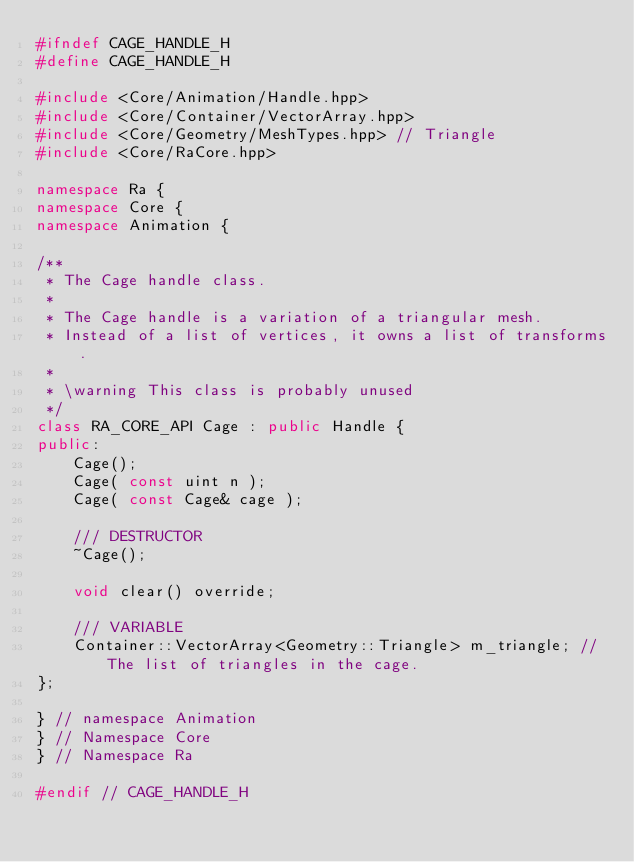<code> <loc_0><loc_0><loc_500><loc_500><_C++_>#ifndef CAGE_HANDLE_H
#define CAGE_HANDLE_H

#include <Core/Animation/Handle.hpp>
#include <Core/Container/VectorArray.hpp>
#include <Core/Geometry/MeshTypes.hpp> // Triangle
#include <Core/RaCore.hpp>

namespace Ra {
namespace Core {
namespace Animation {

/**
 * The Cage handle class.
 *
 * The Cage handle is a variation of a triangular mesh.
 * Instead of a list of vertices, it owns a list of transforms.
 *
 * \warning This class is probably unused
 */
class RA_CORE_API Cage : public Handle {
public:
    Cage();
    Cage( const uint n );
    Cage( const Cage& cage );

    /// DESTRUCTOR
    ~Cage();

    void clear() override;

    /// VARIABLE
    Container::VectorArray<Geometry::Triangle> m_triangle; // The list of triangles in the cage.
};

} // namespace Animation
} // Namespace Core
} // Namespace Ra

#endif // CAGE_HANDLE_H
</code> 